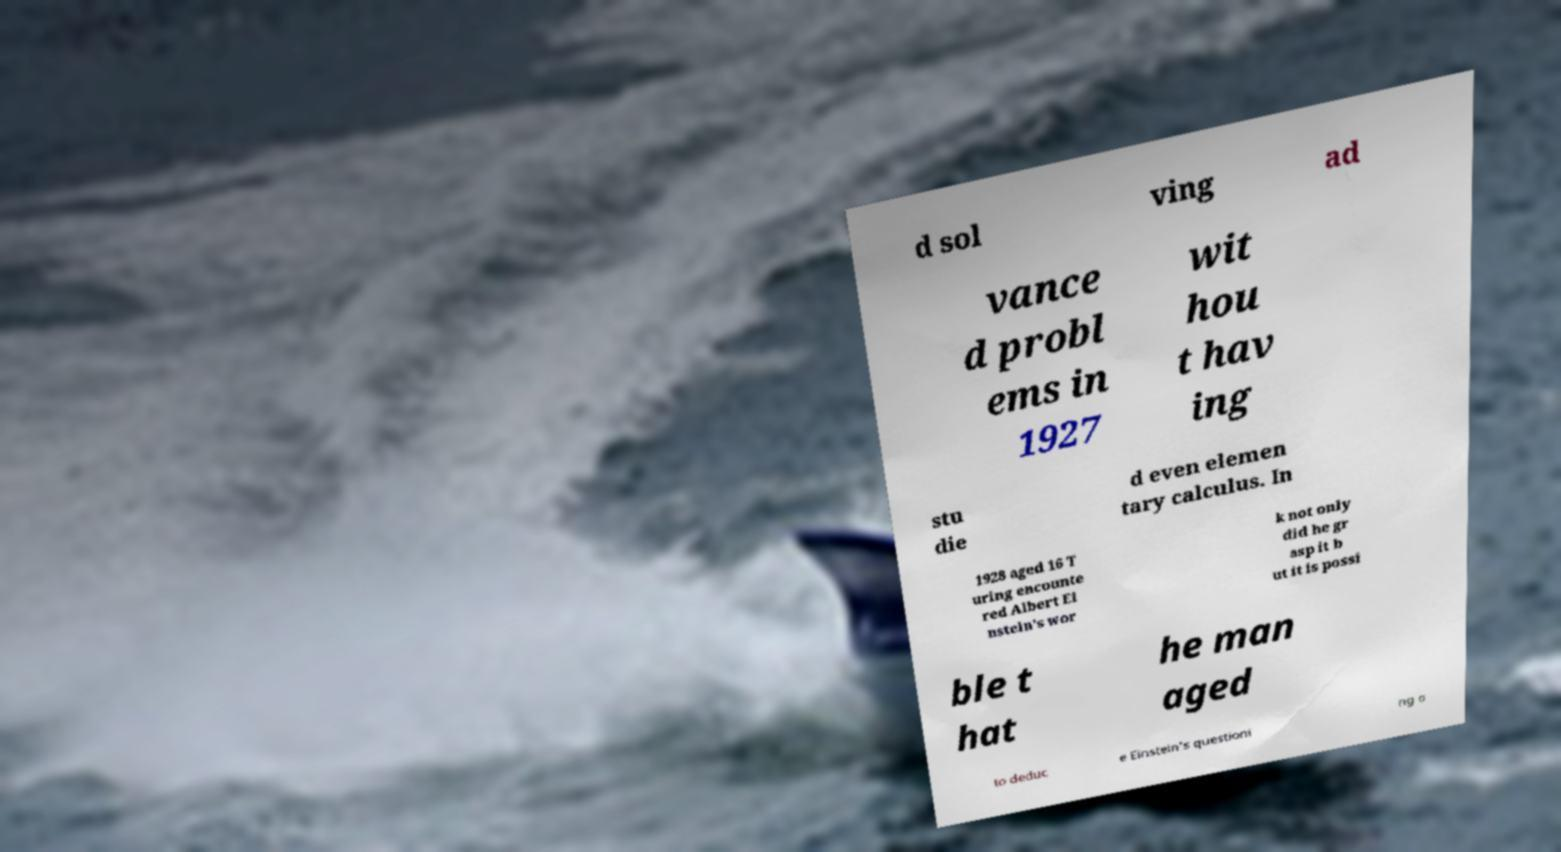What messages or text are displayed in this image? I need them in a readable, typed format. d sol ving ad vance d probl ems in 1927 wit hou t hav ing stu die d even elemen tary calculus. In 1928 aged 16 T uring encounte red Albert Ei nstein's wor k not only did he gr asp it b ut it is possi ble t hat he man aged to deduc e Einstein's questioni ng o 